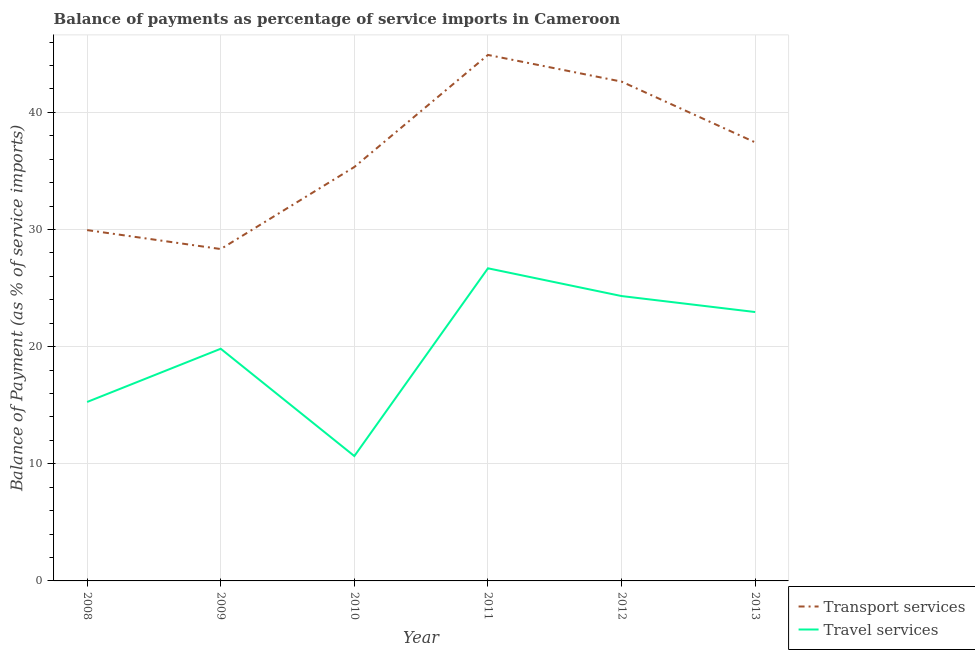What is the balance of payments of travel services in 2013?
Give a very brief answer. 22.95. Across all years, what is the maximum balance of payments of travel services?
Offer a terse response. 26.69. Across all years, what is the minimum balance of payments of travel services?
Provide a succinct answer. 10.66. In which year was the balance of payments of travel services maximum?
Offer a very short reply. 2011. What is the total balance of payments of travel services in the graph?
Provide a short and direct response. 119.7. What is the difference between the balance of payments of travel services in 2008 and that in 2012?
Keep it short and to the point. -9.04. What is the difference between the balance of payments of transport services in 2010 and the balance of payments of travel services in 2008?
Provide a short and direct response. 20.06. What is the average balance of payments of transport services per year?
Your response must be concise. 36.43. In the year 2013, what is the difference between the balance of payments of travel services and balance of payments of transport services?
Provide a succinct answer. -14.48. What is the ratio of the balance of payments of travel services in 2010 to that in 2012?
Make the answer very short. 0.44. What is the difference between the highest and the second highest balance of payments of transport services?
Give a very brief answer. 2.28. What is the difference between the highest and the lowest balance of payments of travel services?
Give a very brief answer. 16.03. Is the sum of the balance of payments of transport services in 2008 and 2013 greater than the maximum balance of payments of travel services across all years?
Provide a succinct answer. Yes. Is the balance of payments of travel services strictly greater than the balance of payments of transport services over the years?
Make the answer very short. No. How many years are there in the graph?
Ensure brevity in your answer.  6. Does the graph contain any zero values?
Provide a short and direct response. No. How many legend labels are there?
Offer a very short reply. 2. How are the legend labels stacked?
Your answer should be compact. Vertical. What is the title of the graph?
Make the answer very short. Balance of payments as percentage of service imports in Cameroon. What is the label or title of the X-axis?
Offer a terse response. Year. What is the label or title of the Y-axis?
Your answer should be very brief. Balance of Payment (as % of service imports). What is the Balance of Payment (as % of service imports) of Transport services in 2008?
Your response must be concise. 29.95. What is the Balance of Payment (as % of service imports) of Travel services in 2008?
Make the answer very short. 15.27. What is the Balance of Payment (as % of service imports) of Transport services in 2009?
Provide a short and direct response. 28.33. What is the Balance of Payment (as % of service imports) of Travel services in 2009?
Make the answer very short. 19.82. What is the Balance of Payment (as % of service imports) of Transport services in 2010?
Offer a terse response. 35.33. What is the Balance of Payment (as % of service imports) in Travel services in 2010?
Make the answer very short. 10.66. What is the Balance of Payment (as % of service imports) of Transport services in 2011?
Provide a short and direct response. 44.9. What is the Balance of Payment (as % of service imports) in Travel services in 2011?
Your answer should be very brief. 26.69. What is the Balance of Payment (as % of service imports) of Transport services in 2012?
Provide a short and direct response. 42.62. What is the Balance of Payment (as % of service imports) in Travel services in 2012?
Ensure brevity in your answer.  24.32. What is the Balance of Payment (as % of service imports) of Transport services in 2013?
Provide a short and direct response. 37.43. What is the Balance of Payment (as % of service imports) of Travel services in 2013?
Your answer should be very brief. 22.95. Across all years, what is the maximum Balance of Payment (as % of service imports) of Transport services?
Give a very brief answer. 44.9. Across all years, what is the maximum Balance of Payment (as % of service imports) of Travel services?
Provide a succinct answer. 26.69. Across all years, what is the minimum Balance of Payment (as % of service imports) of Transport services?
Offer a terse response. 28.33. Across all years, what is the minimum Balance of Payment (as % of service imports) of Travel services?
Make the answer very short. 10.66. What is the total Balance of Payment (as % of service imports) of Transport services in the graph?
Make the answer very short. 218.56. What is the total Balance of Payment (as % of service imports) in Travel services in the graph?
Give a very brief answer. 119.7. What is the difference between the Balance of Payment (as % of service imports) in Transport services in 2008 and that in 2009?
Keep it short and to the point. 1.62. What is the difference between the Balance of Payment (as % of service imports) of Travel services in 2008 and that in 2009?
Provide a succinct answer. -4.54. What is the difference between the Balance of Payment (as % of service imports) in Transport services in 2008 and that in 2010?
Keep it short and to the point. -5.39. What is the difference between the Balance of Payment (as % of service imports) in Travel services in 2008 and that in 2010?
Offer a very short reply. 4.62. What is the difference between the Balance of Payment (as % of service imports) in Transport services in 2008 and that in 2011?
Ensure brevity in your answer.  -14.95. What is the difference between the Balance of Payment (as % of service imports) in Travel services in 2008 and that in 2011?
Provide a succinct answer. -11.41. What is the difference between the Balance of Payment (as % of service imports) in Transport services in 2008 and that in 2012?
Your answer should be very brief. -12.68. What is the difference between the Balance of Payment (as % of service imports) in Travel services in 2008 and that in 2012?
Give a very brief answer. -9.04. What is the difference between the Balance of Payment (as % of service imports) in Transport services in 2008 and that in 2013?
Make the answer very short. -7.49. What is the difference between the Balance of Payment (as % of service imports) of Travel services in 2008 and that in 2013?
Your response must be concise. -7.68. What is the difference between the Balance of Payment (as % of service imports) in Transport services in 2009 and that in 2010?
Give a very brief answer. -7. What is the difference between the Balance of Payment (as % of service imports) of Travel services in 2009 and that in 2010?
Provide a succinct answer. 9.16. What is the difference between the Balance of Payment (as % of service imports) of Transport services in 2009 and that in 2011?
Offer a very short reply. -16.57. What is the difference between the Balance of Payment (as % of service imports) of Travel services in 2009 and that in 2011?
Your answer should be very brief. -6.87. What is the difference between the Balance of Payment (as % of service imports) in Transport services in 2009 and that in 2012?
Provide a short and direct response. -14.29. What is the difference between the Balance of Payment (as % of service imports) in Travel services in 2009 and that in 2012?
Provide a short and direct response. -4.5. What is the difference between the Balance of Payment (as % of service imports) in Transport services in 2009 and that in 2013?
Your answer should be compact. -9.11. What is the difference between the Balance of Payment (as % of service imports) in Travel services in 2009 and that in 2013?
Your answer should be very brief. -3.13. What is the difference between the Balance of Payment (as % of service imports) of Transport services in 2010 and that in 2011?
Offer a terse response. -9.57. What is the difference between the Balance of Payment (as % of service imports) in Travel services in 2010 and that in 2011?
Your answer should be compact. -16.03. What is the difference between the Balance of Payment (as % of service imports) of Transport services in 2010 and that in 2012?
Keep it short and to the point. -7.29. What is the difference between the Balance of Payment (as % of service imports) of Travel services in 2010 and that in 2012?
Your answer should be very brief. -13.66. What is the difference between the Balance of Payment (as % of service imports) of Transport services in 2010 and that in 2013?
Offer a terse response. -2.1. What is the difference between the Balance of Payment (as % of service imports) of Travel services in 2010 and that in 2013?
Your answer should be compact. -12.29. What is the difference between the Balance of Payment (as % of service imports) of Transport services in 2011 and that in 2012?
Offer a very short reply. 2.28. What is the difference between the Balance of Payment (as % of service imports) in Travel services in 2011 and that in 2012?
Make the answer very short. 2.37. What is the difference between the Balance of Payment (as % of service imports) in Transport services in 2011 and that in 2013?
Your answer should be very brief. 7.46. What is the difference between the Balance of Payment (as % of service imports) in Travel services in 2011 and that in 2013?
Make the answer very short. 3.73. What is the difference between the Balance of Payment (as % of service imports) in Transport services in 2012 and that in 2013?
Keep it short and to the point. 5.19. What is the difference between the Balance of Payment (as % of service imports) of Travel services in 2012 and that in 2013?
Ensure brevity in your answer.  1.36. What is the difference between the Balance of Payment (as % of service imports) in Transport services in 2008 and the Balance of Payment (as % of service imports) in Travel services in 2009?
Ensure brevity in your answer.  10.13. What is the difference between the Balance of Payment (as % of service imports) of Transport services in 2008 and the Balance of Payment (as % of service imports) of Travel services in 2010?
Keep it short and to the point. 19.29. What is the difference between the Balance of Payment (as % of service imports) of Transport services in 2008 and the Balance of Payment (as % of service imports) of Travel services in 2011?
Offer a terse response. 3.26. What is the difference between the Balance of Payment (as % of service imports) of Transport services in 2008 and the Balance of Payment (as % of service imports) of Travel services in 2012?
Make the answer very short. 5.63. What is the difference between the Balance of Payment (as % of service imports) of Transport services in 2008 and the Balance of Payment (as % of service imports) of Travel services in 2013?
Your answer should be compact. 6.99. What is the difference between the Balance of Payment (as % of service imports) of Transport services in 2009 and the Balance of Payment (as % of service imports) of Travel services in 2010?
Your response must be concise. 17.67. What is the difference between the Balance of Payment (as % of service imports) in Transport services in 2009 and the Balance of Payment (as % of service imports) in Travel services in 2011?
Provide a succinct answer. 1.64. What is the difference between the Balance of Payment (as % of service imports) in Transport services in 2009 and the Balance of Payment (as % of service imports) in Travel services in 2012?
Your answer should be very brief. 4.01. What is the difference between the Balance of Payment (as % of service imports) of Transport services in 2009 and the Balance of Payment (as % of service imports) of Travel services in 2013?
Make the answer very short. 5.38. What is the difference between the Balance of Payment (as % of service imports) of Transport services in 2010 and the Balance of Payment (as % of service imports) of Travel services in 2011?
Ensure brevity in your answer.  8.65. What is the difference between the Balance of Payment (as % of service imports) in Transport services in 2010 and the Balance of Payment (as % of service imports) in Travel services in 2012?
Offer a very short reply. 11.02. What is the difference between the Balance of Payment (as % of service imports) of Transport services in 2010 and the Balance of Payment (as % of service imports) of Travel services in 2013?
Your response must be concise. 12.38. What is the difference between the Balance of Payment (as % of service imports) of Transport services in 2011 and the Balance of Payment (as % of service imports) of Travel services in 2012?
Your response must be concise. 20.58. What is the difference between the Balance of Payment (as % of service imports) of Transport services in 2011 and the Balance of Payment (as % of service imports) of Travel services in 2013?
Your response must be concise. 21.95. What is the difference between the Balance of Payment (as % of service imports) of Transport services in 2012 and the Balance of Payment (as % of service imports) of Travel services in 2013?
Your response must be concise. 19.67. What is the average Balance of Payment (as % of service imports) in Transport services per year?
Your answer should be very brief. 36.43. What is the average Balance of Payment (as % of service imports) of Travel services per year?
Offer a very short reply. 19.95. In the year 2008, what is the difference between the Balance of Payment (as % of service imports) of Transport services and Balance of Payment (as % of service imports) of Travel services?
Offer a terse response. 14.67. In the year 2009, what is the difference between the Balance of Payment (as % of service imports) of Transport services and Balance of Payment (as % of service imports) of Travel services?
Provide a succinct answer. 8.51. In the year 2010, what is the difference between the Balance of Payment (as % of service imports) in Transport services and Balance of Payment (as % of service imports) in Travel services?
Provide a short and direct response. 24.67. In the year 2011, what is the difference between the Balance of Payment (as % of service imports) of Transport services and Balance of Payment (as % of service imports) of Travel services?
Make the answer very short. 18.21. In the year 2012, what is the difference between the Balance of Payment (as % of service imports) in Transport services and Balance of Payment (as % of service imports) in Travel services?
Your answer should be very brief. 18.3. In the year 2013, what is the difference between the Balance of Payment (as % of service imports) in Transport services and Balance of Payment (as % of service imports) in Travel services?
Give a very brief answer. 14.48. What is the ratio of the Balance of Payment (as % of service imports) of Transport services in 2008 to that in 2009?
Give a very brief answer. 1.06. What is the ratio of the Balance of Payment (as % of service imports) of Travel services in 2008 to that in 2009?
Make the answer very short. 0.77. What is the ratio of the Balance of Payment (as % of service imports) in Transport services in 2008 to that in 2010?
Keep it short and to the point. 0.85. What is the ratio of the Balance of Payment (as % of service imports) in Travel services in 2008 to that in 2010?
Give a very brief answer. 1.43. What is the ratio of the Balance of Payment (as % of service imports) of Transport services in 2008 to that in 2011?
Your response must be concise. 0.67. What is the ratio of the Balance of Payment (as % of service imports) in Travel services in 2008 to that in 2011?
Your answer should be very brief. 0.57. What is the ratio of the Balance of Payment (as % of service imports) of Transport services in 2008 to that in 2012?
Your answer should be very brief. 0.7. What is the ratio of the Balance of Payment (as % of service imports) in Travel services in 2008 to that in 2012?
Provide a succinct answer. 0.63. What is the ratio of the Balance of Payment (as % of service imports) of Travel services in 2008 to that in 2013?
Make the answer very short. 0.67. What is the ratio of the Balance of Payment (as % of service imports) of Transport services in 2009 to that in 2010?
Offer a terse response. 0.8. What is the ratio of the Balance of Payment (as % of service imports) in Travel services in 2009 to that in 2010?
Give a very brief answer. 1.86. What is the ratio of the Balance of Payment (as % of service imports) in Transport services in 2009 to that in 2011?
Keep it short and to the point. 0.63. What is the ratio of the Balance of Payment (as % of service imports) of Travel services in 2009 to that in 2011?
Your answer should be compact. 0.74. What is the ratio of the Balance of Payment (as % of service imports) in Transport services in 2009 to that in 2012?
Ensure brevity in your answer.  0.66. What is the ratio of the Balance of Payment (as % of service imports) in Travel services in 2009 to that in 2012?
Ensure brevity in your answer.  0.81. What is the ratio of the Balance of Payment (as % of service imports) of Transport services in 2009 to that in 2013?
Offer a very short reply. 0.76. What is the ratio of the Balance of Payment (as % of service imports) of Travel services in 2009 to that in 2013?
Provide a succinct answer. 0.86. What is the ratio of the Balance of Payment (as % of service imports) of Transport services in 2010 to that in 2011?
Offer a very short reply. 0.79. What is the ratio of the Balance of Payment (as % of service imports) in Travel services in 2010 to that in 2011?
Offer a terse response. 0.4. What is the ratio of the Balance of Payment (as % of service imports) in Transport services in 2010 to that in 2012?
Your answer should be compact. 0.83. What is the ratio of the Balance of Payment (as % of service imports) in Travel services in 2010 to that in 2012?
Ensure brevity in your answer.  0.44. What is the ratio of the Balance of Payment (as % of service imports) in Transport services in 2010 to that in 2013?
Offer a very short reply. 0.94. What is the ratio of the Balance of Payment (as % of service imports) of Travel services in 2010 to that in 2013?
Your answer should be very brief. 0.46. What is the ratio of the Balance of Payment (as % of service imports) in Transport services in 2011 to that in 2012?
Provide a succinct answer. 1.05. What is the ratio of the Balance of Payment (as % of service imports) in Travel services in 2011 to that in 2012?
Keep it short and to the point. 1.1. What is the ratio of the Balance of Payment (as % of service imports) in Transport services in 2011 to that in 2013?
Your response must be concise. 1.2. What is the ratio of the Balance of Payment (as % of service imports) in Travel services in 2011 to that in 2013?
Ensure brevity in your answer.  1.16. What is the ratio of the Balance of Payment (as % of service imports) in Transport services in 2012 to that in 2013?
Your answer should be compact. 1.14. What is the ratio of the Balance of Payment (as % of service imports) of Travel services in 2012 to that in 2013?
Provide a short and direct response. 1.06. What is the difference between the highest and the second highest Balance of Payment (as % of service imports) of Transport services?
Provide a succinct answer. 2.28. What is the difference between the highest and the second highest Balance of Payment (as % of service imports) in Travel services?
Your response must be concise. 2.37. What is the difference between the highest and the lowest Balance of Payment (as % of service imports) of Transport services?
Make the answer very short. 16.57. What is the difference between the highest and the lowest Balance of Payment (as % of service imports) in Travel services?
Offer a very short reply. 16.03. 